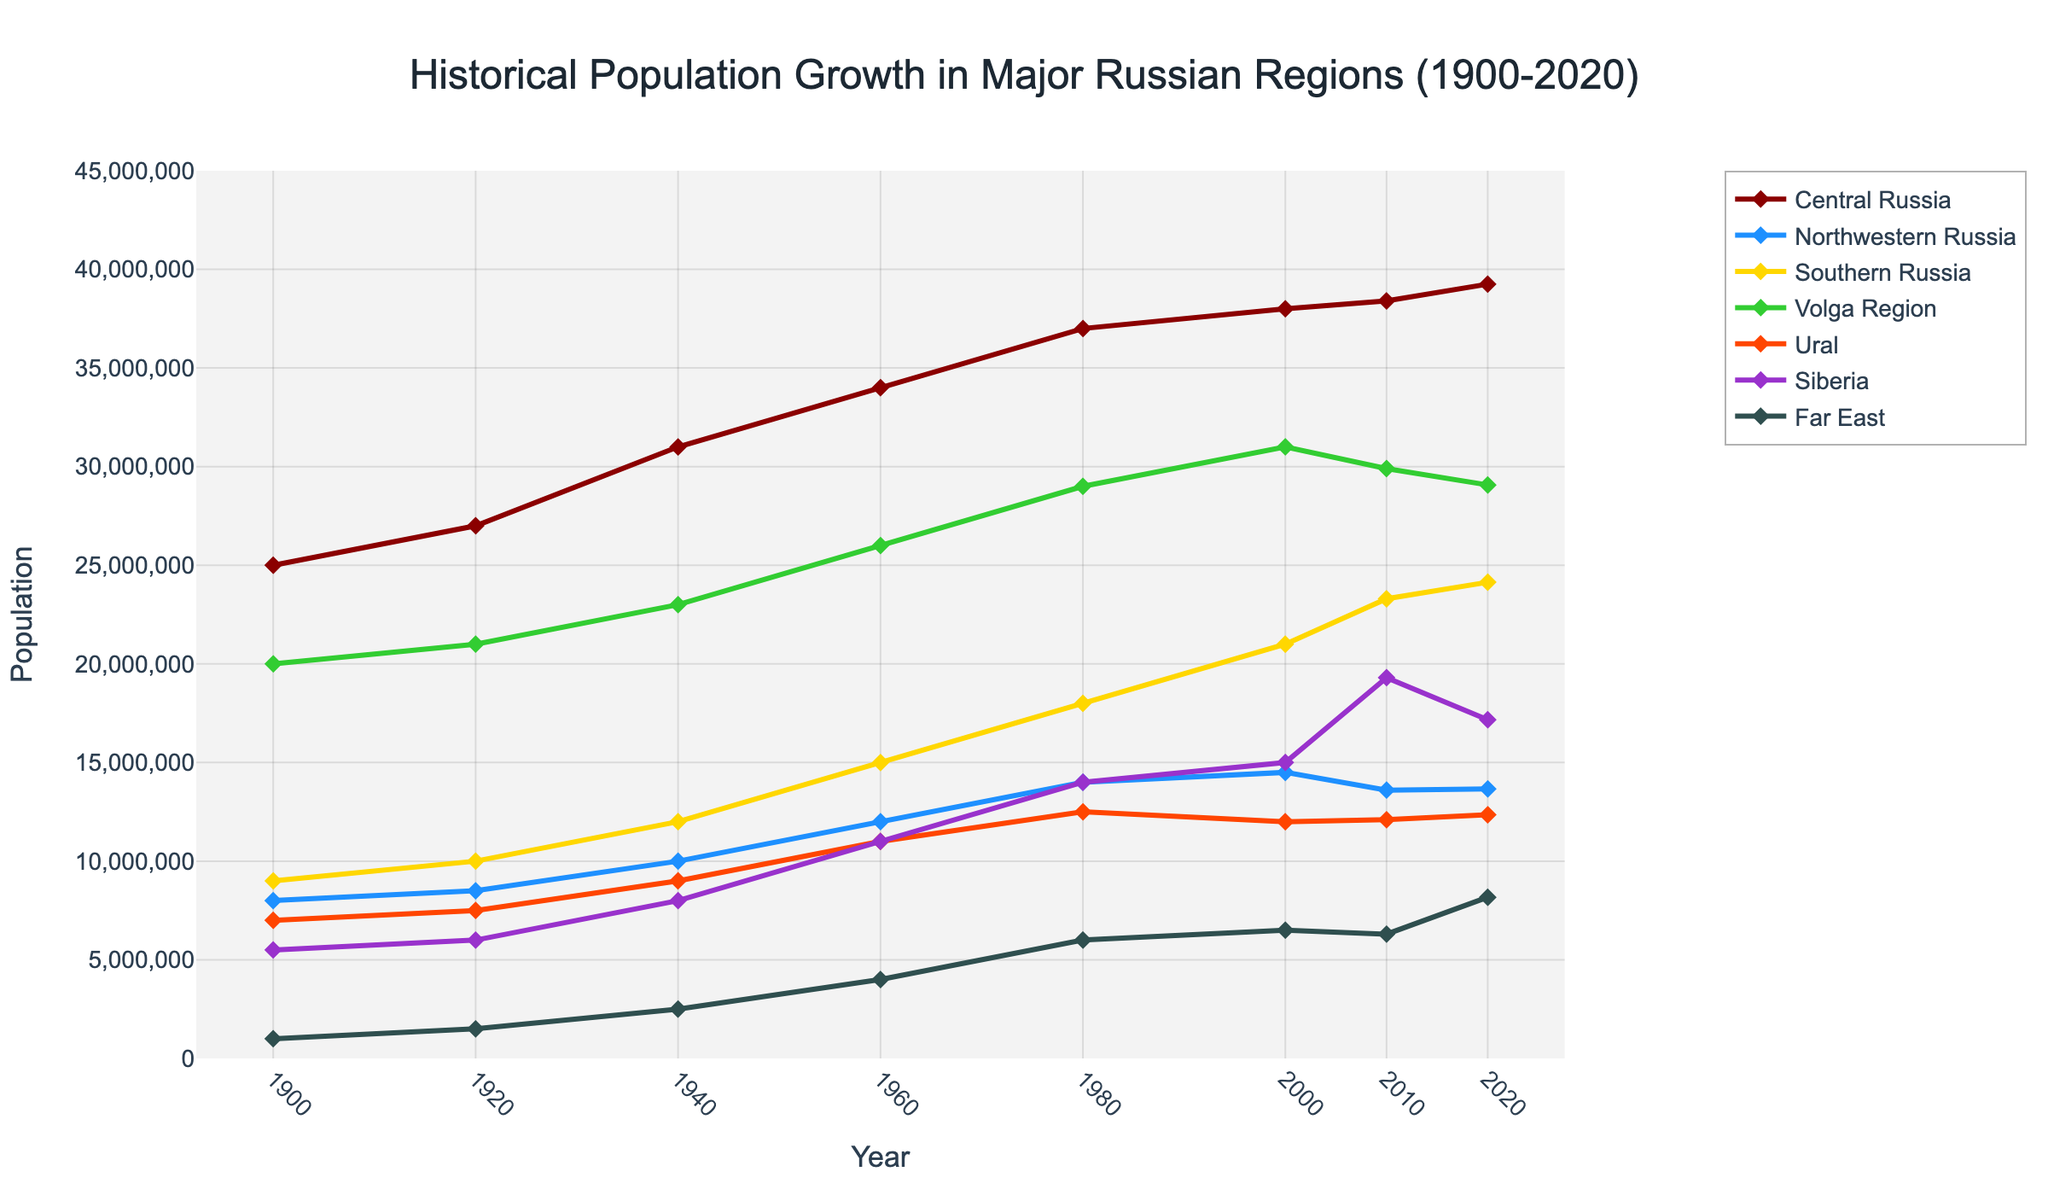What's the difference in population between Central Russia and Siberia in 2020? In 2020, the population of Central Russia is 39,250,000, and for Siberia, it is 17,170,000. The difference is 39,250,000 - 17,170,000.
Answer: 22,080,000 Which region had the highest population growth between 1900 and 2020? The population in 1900 and 2020 for each region needs to be compared: Central Russia (25,000,000 to 39,250,000), Northwestern Russia (8,000,000 to 13,660,000), Southern Russia (9,000,000 to 24,140,000), Volga Region (20,000,000 to 29,070,000), Ural (7,000,000 to 12,350,000), Siberia (5,500,000 to 17,170,000), Far East (1,000,000 to 8,170,000). The highest growth occurs in Southern Russia with an increase of 15,140,000 (24,140,000 - 9,000,000).
Answer: Southern Russia What visual marker is used to denote the data points on the lines? Each data point on the lines is marked by a diamond shape as can be observed on the figure.
Answer: Diamond What is the average population of the Northwestern Russia region from 1900 to 2020? First, sum the populations at each time point: 8,000,000 + 8,500,000 + 10,000,000 + 12,000,000 + 14,000,000 + 14,500,000 + 13,600,000 + 13,660,000 = 94,260,000. There are 8 data points, so the average is 94,260,000 / 8.
Answer: 11,782,500 Which regions had a population decrease between 2000 and 2020? To find regions with population decreases from 2000 to 2020, check their populations in these years respectively: Central Russia (38,000,000 to 39,250,000), Northwestern Russia (14,500,000 to 13,660,000), Southern Russia (21,000,000 to 24,140,000), Volga Region (31,000,000 to 29,070,000), Ural (12,000,000 to 12,350,000), Siberia (15,000,000 to 17,170,000), Far East (6,500,000 to 8,170,000). Regions with decreases are Northwestern Russia and Volga Region.
Answer: Northwestern Russia, Volga Region Which region's population shows the most significant increase from 2010 to 2020? Comparing population changes from 2010 to 2020: Central Russia (38,400,000 to 39,250,000), Northwestern Russia (13,600,000 to 13,660,000), Southern Russia (23,300,000 to 24,140,000), Volga Region (29,900,000 to 29,070,000), Ural (12,100,000 to 12,350,000), Siberia (19,300,000 to 17,170,000), Far East (6,300,000 to 8,170,000). Southern Russia has the most significant increase with 840,000 (24,140,000 - 23,300,000).
Answer: Southern Russia What is the population trend of the Far East region from 1900 to 2020? Observing the population values of the Far East region from 1900 (1,000,000) to 2020 (8,170,000), it shows continuous growth. Hence, the trend is upward.
Answer: Upward How does the growth of the Ural region between 1960 and 1980 compare to that of the Volga Region in the same period? The population of Ural in 1960 is 11,000,000 and in 1980 is 12,500,000, a difference of 1,500,000. The Volga Region in 1960 is 26,000,000 and in 1980 is 29,000,000, a difference of 3,000,000. Thus, Volga’s growth is double that of Ural.
Answer: Volga Region doubled Ural's growth What's the total population of all regions combined in 1920? Add the populations of all regions in 1920: 27,000,000 + 8,500,000 + 10,000,000 + 21,000,000 + 7,500,000 + 6,000,000 + 1,500,000 = 81,500,000.
Answer: 81,500,000 